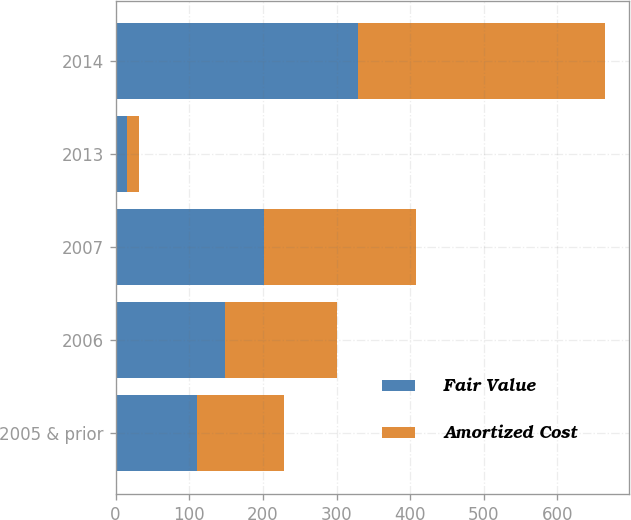Convert chart. <chart><loc_0><loc_0><loc_500><loc_500><stacked_bar_chart><ecel><fcel>2005 & prior<fcel>2006<fcel>2007<fcel>2013<fcel>2014<nl><fcel>Fair Value<fcel>110<fcel>149<fcel>202<fcel>16<fcel>329<nl><fcel>Amortized Cost<fcel>119<fcel>151<fcel>206<fcel>16<fcel>335<nl></chart> 